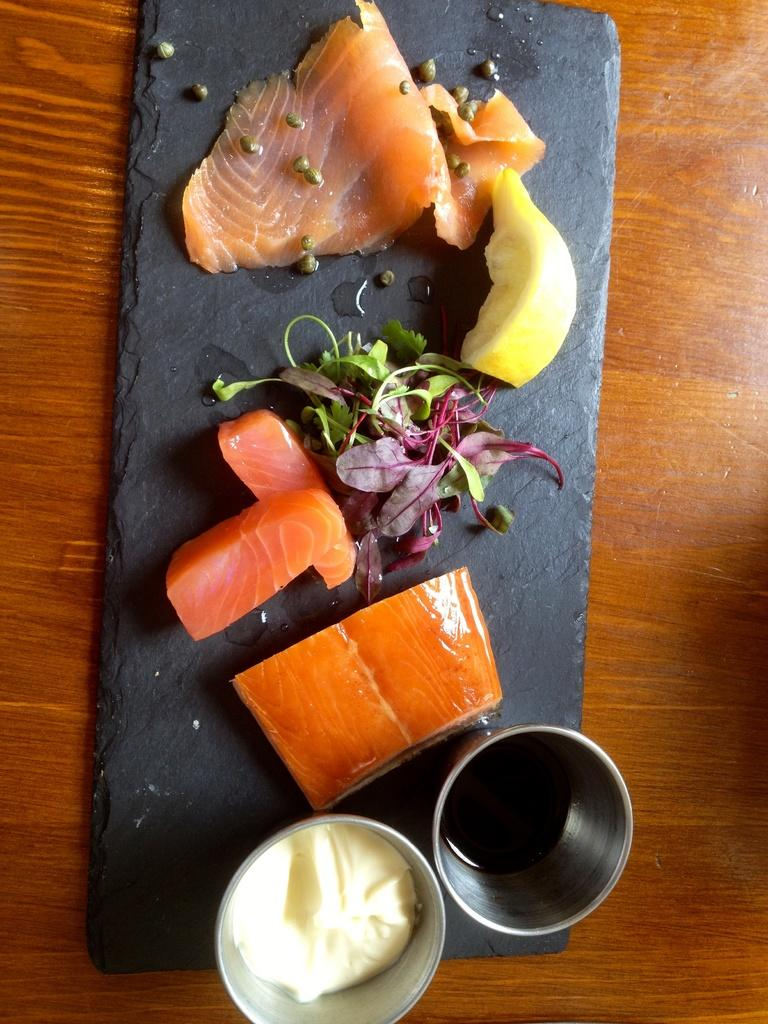What type of objects can be seen in the image? There are flesh pieces in the image. What is the color of the stone on which other objects are placed? The stone is black in color. What type of bowls are present at the bottom of the image? There are stainless bowls at the bottom of the image. How many locks can be seen securing the flesh pieces in the image? There are no locks present in the image; the flesh pieces are not secured. 